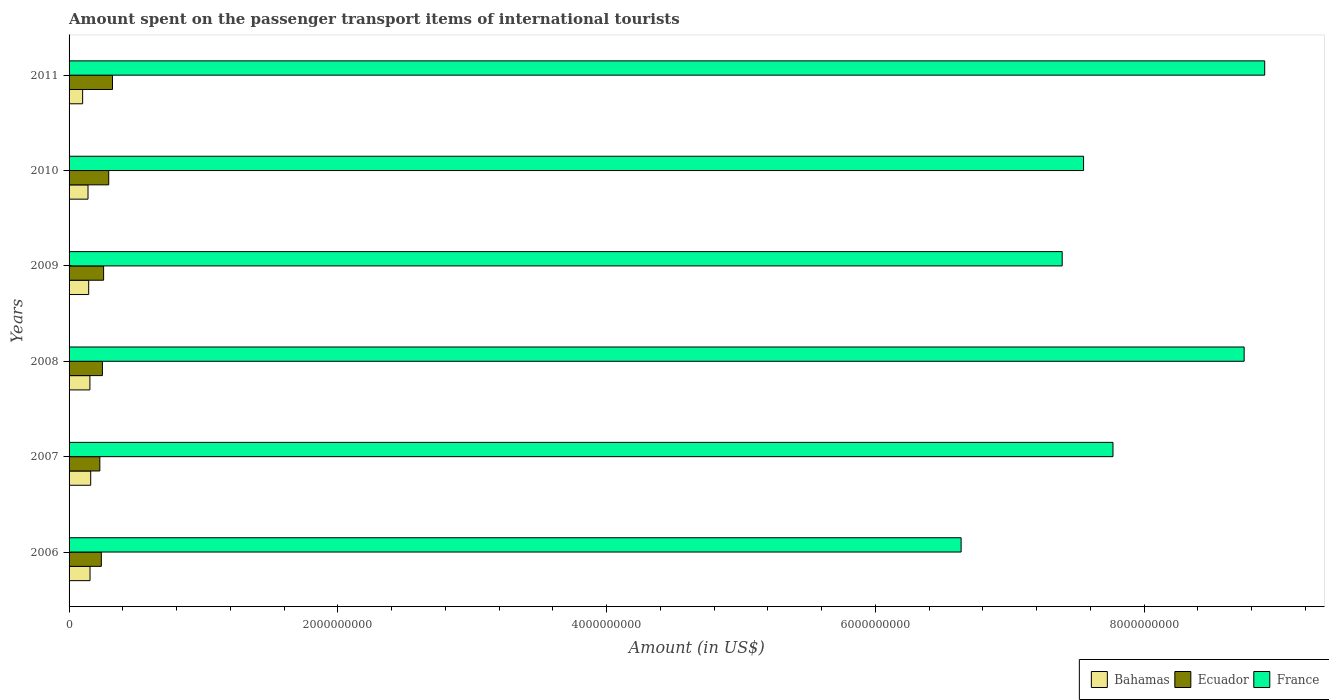How many groups of bars are there?
Keep it short and to the point. 6. Are the number of bars on each tick of the Y-axis equal?
Provide a succinct answer. Yes. How many bars are there on the 3rd tick from the bottom?
Keep it short and to the point. 3. What is the label of the 5th group of bars from the top?
Offer a terse response. 2007. In how many cases, is the number of bars for a given year not equal to the number of legend labels?
Offer a terse response. 0. What is the amount spent on the passenger transport items of international tourists in France in 2007?
Keep it short and to the point. 7.77e+09. Across all years, what is the maximum amount spent on the passenger transport items of international tourists in France?
Make the answer very short. 8.90e+09. Across all years, what is the minimum amount spent on the passenger transport items of international tourists in Ecuador?
Provide a succinct answer. 2.29e+08. In which year was the amount spent on the passenger transport items of international tourists in Bahamas minimum?
Ensure brevity in your answer.  2011. What is the total amount spent on the passenger transport items of international tourists in France in the graph?
Provide a succinct answer. 4.70e+1. What is the difference between the amount spent on the passenger transport items of international tourists in France in 2009 and that in 2011?
Provide a succinct answer. -1.51e+09. What is the difference between the amount spent on the passenger transport items of international tourists in France in 2011 and the amount spent on the passenger transport items of international tourists in Ecuador in 2007?
Offer a terse response. 8.67e+09. What is the average amount spent on the passenger transport items of international tourists in Bahamas per year?
Make the answer very short. 1.43e+08. In the year 2008, what is the difference between the amount spent on the passenger transport items of international tourists in Ecuador and amount spent on the passenger transport items of international tourists in France?
Your answer should be very brief. -8.50e+09. In how many years, is the amount spent on the passenger transport items of international tourists in Ecuador greater than 400000000 US$?
Make the answer very short. 0. What is the ratio of the amount spent on the passenger transport items of international tourists in Bahamas in 2008 to that in 2009?
Your answer should be very brief. 1.06. Is the amount spent on the passenger transport items of international tourists in Bahamas in 2006 less than that in 2011?
Give a very brief answer. No. What is the difference between the highest and the second highest amount spent on the passenger transport items of international tourists in Ecuador?
Your answer should be very brief. 2.80e+07. What is the difference between the highest and the lowest amount spent on the passenger transport items of international tourists in Bahamas?
Your response must be concise. 6.00e+07. What does the 3rd bar from the top in 2008 represents?
Give a very brief answer. Bahamas. What does the 2nd bar from the bottom in 2008 represents?
Your answer should be compact. Ecuador. Is it the case that in every year, the sum of the amount spent on the passenger transport items of international tourists in Ecuador and amount spent on the passenger transport items of international tourists in Bahamas is greater than the amount spent on the passenger transport items of international tourists in France?
Make the answer very short. No. How many years are there in the graph?
Your response must be concise. 6. Are the values on the major ticks of X-axis written in scientific E-notation?
Ensure brevity in your answer.  No. Does the graph contain any zero values?
Provide a short and direct response. No. Does the graph contain grids?
Give a very brief answer. No. Where does the legend appear in the graph?
Provide a short and direct response. Bottom right. How many legend labels are there?
Ensure brevity in your answer.  3. How are the legend labels stacked?
Give a very brief answer. Horizontal. What is the title of the graph?
Offer a very short reply. Amount spent on the passenger transport items of international tourists. What is the label or title of the Y-axis?
Make the answer very short. Years. What is the Amount (in US$) in Bahamas in 2006?
Your response must be concise. 1.56e+08. What is the Amount (in US$) of Ecuador in 2006?
Offer a terse response. 2.40e+08. What is the Amount (in US$) in France in 2006?
Keep it short and to the point. 6.64e+09. What is the Amount (in US$) in Bahamas in 2007?
Provide a short and direct response. 1.61e+08. What is the Amount (in US$) of Ecuador in 2007?
Provide a succinct answer. 2.29e+08. What is the Amount (in US$) in France in 2007?
Ensure brevity in your answer.  7.77e+09. What is the Amount (in US$) in Bahamas in 2008?
Make the answer very short. 1.55e+08. What is the Amount (in US$) of Ecuador in 2008?
Offer a terse response. 2.48e+08. What is the Amount (in US$) in France in 2008?
Ensure brevity in your answer.  8.74e+09. What is the Amount (in US$) of Bahamas in 2009?
Give a very brief answer. 1.46e+08. What is the Amount (in US$) of Ecuador in 2009?
Your response must be concise. 2.57e+08. What is the Amount (in US$) in France in 2009?
Provide a succinct answer. 7.39e+09. What is the Amount (in US$) in Bahamas in 2010?
Offer a terse response. 1.41e+08. What is the Amount (in US$) in Ecuador in 2010?
Your answer should be very brief. 2.95e+08. What is the Amount (in US$) of France in 2010?
Ensure brevity in your answer.  7.55e+09. What is the Amount (in US$) of Bahamas in 2011?
Provide a succinct answer. 1.01e+08. What is the Amount (in US$) in Ecuador in 2011?
Give a very brief answer. 3.23e+08. What is the Amount (in US$) in France in 2011?
Provide a succinct answer. 8.90e+09. Across all years, what is the maximum Amount (in US$) of Bahamas?
Your response must be concise. 1.61e+08. Across all years, what is the maximum Amount (in US$) in Ecuador?
Offer a very short reply. 3.23e+08. Across all years, what is the maximum Amount (in US$) of France?
Your answer should be very brief. 8.90e+09. Across all years, what is the minimum Amount (in US$) of Bahamas?
Provide a short and direct response. 1.01e+08. Across all years, what is the minimum Amount (in US$) of Ecuador?
Offer a terse response. 2.29e+08. Across all years, what is the minimum Amount (in US$) of France?
Your answer should be compact. 6.64e+09. What is the total Amount (in US$) in Bahamas in the graph?
Offer a terse response. 8.60e+08. What is the total Amount (in US$) in Ecuador in the graph?
Offer a terse response. 1.59e+09. What is the total Amount (in US$) of France in the graph?
Give a very brief answer. 4.70e+1. What is the difference between the Amount (in US$) of Bahamas in 2006 and that in 2007?
Keep it short and to the point. -5.00e+06. What is the difference between the Amount (in US$) in Ecuador in 2006 and that in 2007?
Offer a very short reply. 1.10e+07. What is the difference between the Amount (in US$) of France in 2006 and that in 2007?
Your response must be concise. -1.13e+09. What is the difference between the Amount (in US$) of Ecuador in 2006 and that in 2008?
Your answer should be very brief. -8.00e+06. What is the difference between the Amount (in US$) in France in 2006 and that in 2008?
Make the answer very short. -2.11e+09. What is the difference between the Amount (in US$) in Ecuador in 2006 and that in 2009?
Your answer should be very brief. -1.70e+07. What is the difference between the Amount (in US$) in France in 2006 and that in 2009?
Offer a terse response. -7.52e+08. What is the difference between the Amount (in US$) in Bahamas in 2006 and that in 2010?
Offer a very short reply. 1.50e+07. What is the difference between the Amount (in US$) of Ecuador in 2006 and that in 2010?
Your response must be concise. -5.50e+07. What is the difference between the Amount (in US$) in France in 2006 and that in 2010?
Make the answer very short. -9.11e+08. What is the difference between the Amount (in US$) of Bahamas in 2006 and that in 2011?
Make the answer very short. 5.50e+07. What is the difference between the Amount (in US$) of Ecuador in 2006 and that in 2011?
Your answer should be very brief. -8.30e+07. What is the difference between the Amount (in US$) of France in 2006 and that in 2011?
Offer a terse response. -2.26e+09. What is the difference between the Amount (in US$) of Bahamas in 2007 and that in 2008?
Your answer should be compact. 6.00e+06. What is the difference between the Amount (in US$) of Ecuador in 2007 and that in 2008?
Give a very brief answer. -1.90e+07. What is the difference between the Amount (in US$) of France in 2007 and that in 2008?
Your response must be concise. -9.76e+08. What is the difference between the Amount (in US$) of Bahamas in 2007 and that in 2009?
Provide a succinct answer. 1.50e+07. What is the difference between the Amount (in US$) in Ecuador in 2007 and that in 2009?
Offer a terse response. -2.80e+07. What is the difference between the Amount (in US$) of France in 2007 and that in 2009?
Offer a very short reply. 3.78e+08. What is the difference between the Amount (in US$) in Ecuador in 2007 and that in 2010?
Your response must be concise. -6.60e+07. What is the difference between the Amount (in US$) of France in 2007 and that in 2010?
Provide a short and direct response. 2.19e+08. What is the difference between the Amount (in US$) in Bahamas in 2007 and that in 2011?
Provide a succinct answer. 6.00e+07. What is the difference between the Amount (in US$) in Ecuador in 2007 and that in 2011?
Provide a short and direct response. -9.40e+07. What is the difference between the Amount (in US$) in France in 2007 and that in 2011?
Make the answer very short. -1.13e+09. What is the difference between the Amount (in US$) of Bahamas in 2008 and that in 2009?
Offer a very short reply. 9.00e+06. What is the difference between the Amount (in US$) of Ecuador in 2008 and that in 2009?
Your answer should be very brief. -9.00e+06. What is the difference between the Amount (in US$) of France in 2008 and that in 2009?
Provide a short and direct response. 1.35e+09. What is the difference between the Amount (in US$) in Bahamas in 2008 and that in 2010?
Make the answer very short. 1.40e+07. What is the difference between the Amount (in US$) in Ecuador in 2008 and that in 2010?
Make the answer very short. -4.70e+07. What is the difference between the Amount (in US$) of France in 2008 and that in 2010?
Give a very brief answer. 1.20e+09. What is the difference between the Amount (in US$) in Bahamas in 2008 and that in 2011?
Your answer should be compact. 5.40e+07. What is the difference between the Amount (in US$) of Ecuador in 2008 and that in 2011?
Your answer should be very brief. -7.50e+07. What is the difference between the Amount (in US$) of France in 2008 and that in 2011?
Keep it short and to the point. -1.53e+08. What is the difference between the Amount (in US$) of Bahamas in 2009 and that in 2010?
Provide a short and direct response. 5.00e+06. What is the difference between the Amount (in US$) in Ecuador in 2009 and that in 2010?
Keep it short and to the point. -3.80e+07. What is the difference between the Amount (in US$) in France in 2009 and that in 2010?
Provide a succinct answer. -1.59e+08. What is the difference between the Amount (in US$) of Bahamas in 2009 and that in 2011?
Ensure brevity in your answer.  4.50e+07. What is the difference between the Amount (in US$) in Ecuador in 2009 and that in 2011?
Your answer should be very brief. -6.60e+07. What is the difference between the Amount (in US$) of France in 2009 and that in 2011?
Offer a very short reply. -1.51e+09. What is the difference between the Amount (in US$) of Bahamas in 2010 and that in 2011?
Ensure brevity in your answer.  4.00e+07. What is the difference between the Amount (in US$) in Ecuador in 2010 and that in 2011?
Your answer should be very brief. -2.80e+07. What is the difference between the Amount (in US$) in France in 2010 and that in 2011?
Offer a terse response. -1.35e+09. What is the difference between the Amount (in US$) in Bahamas in 2006 and the Amount (in US$) in Ecuador in 2007?
Your response must be concise. -7.30e+07. What is the difference between the Amount (in US$) in Bahamas in 2006 and the Amount (in US$) in France in 2007?
Give a very brief answer. -7.61e+09. What is the difference between the Amount (in US$) in Ecuador in 2006 and the Amount (in US$) in France in 2007?
Make the answer very short. -7.53e+09. What is the difference between the Amount (in US$) of Bahamas in 2006 and the Amount (in US$) of Ecuador in 2008?
Give a very brief answer. -9.20e+07. What is the difference between the Amount (in US$) in Bahamas in 2006 and the Amount (in US$) in France in 2008?
Give a very brief answer. -8.59e+09. What is the difference between the Amount (in US$) of Ecuador in 2006 and the Amount (in US$) of France in 2008?
Provide a short and direct response. -8.50e+09. What is the difference between the Amount (in US$) of Bahamas in 2006 and the Amount (in US$) of Ecuador in 2009?
Provide a succinct answer. -1.01e+08. What is the difference between the Amount (in US$) in Bahamas in 2006 and the Amount (in US$) in France in 2009?
Offer a terse response. -7.23e+09. What is the difference between the Amount (in US$) of Ecuador in 2006 and the Amount (in US$) of France in 2009?
Your answer should be compact. -7.15e+09. What is the difference between the Amount (in US$) of Bahamas in 2006 and the Amount (in US$) of Ecuador in 2010?
Your response must be concise. -1.39e+08. What is the difference between the Amount (in US$) of Bahamas in 2006 and the Amount (in US$) of France in 2010?
Provide a succinct answer. -7.39e+09. What is the difference between the Amount (in US$) of Ecuador in 2006 and the Amount (in US$) of France in 2010?
Your response must be concise. -7.31e+09. What is the difference between the Amount (in US$) of Bahamas in 2006 and the Amount (in US$) of Ecuador in 2011?
Make the answer very short. -1.67e+08. What is the difference between the Amount (in US$) of Bahamas in 2006 and the Amount (in US$) of France in 2011?
Your answer should be compact. -8.74e+09. What is the difference between the Amount (in US$) of Ecuador in 2006 and the Amount (in US$) of France in 2011?
Provide a short and direct response. -8.66e+09. What is the difference between the Amount (in US$) of Bahamas in 2007 and the Amount (in US$) of Ecuador in 2008?
Your response must be concise. -8.70e+07. What is the difference between the Amount (in US$) of Bahamas in 2007 and the Amount (in US$) of France in 2008?
Make the answer very short. -8.58e+09. What is the difference between the Amount (in US$) of Ecuador in 2007 and the Amount (in US$) of France in 2008?
Keep it short and to the point. -8.52e+09. What is the difference between the Amount (in US$) of Bahamas in 2007 and the Amount (in US$) of Ecuador in 2009?
Offer a very short reply. -9.60e+07. What is the difference between the Amount (in US$) in Bahamas in 2007 and the Amount (in US$) in France in 2009?
Your response must be concise. -7.23e+09. What is the difference between the Amount (in US$) in Ecuador in 2007 and the Amount (in US$) in France in 2009?
Give a very brief answer. -7.16e+09. What is the difference between the Amount (in US$) in Bahamas in 2007 and the Amount (in US$) in Ecuador in 2010?
Your answer should be compact. -1.34e+08. What is the difference between the Amount (in US$) of Bahamas in 2007 and the Amount (in US$) of France in 2010?
Provide a short and direct response. -7.39e+09. What is the difference between the Amount (in US$) in Ecuador in 2007 and the Amount (in US$) in France in 2010?
Provide a short and direct response. -7.32e+09. What is the difference between the Amount (in US$) of Bahamas in 2007 and the Amount (in US$) of Ecuador in 2011?
Your answer should be very brief. -1.62e+08. What is the difference between the Amount (in US$) of Bahamas in 2007 and the Amount (in US$) of France in 2011?
Make the answer very short. -8.74e+09. What is the difference between the Amount (in US$) of Ecuador in 2007 and the Amount (in US$) of France in 2011?
Keep it short and to the point. -8.67e+09. What is the difference between the Amount (in US$) of Bahamas in 2008 and the Amount (in US$) of Ecuador in 2009?
Give a very brief answer. -1.02e+08. What is the difference between the Amount (in US$) of Bahamas in 2008 and the Amount (in US$) of France in 2009?
Provide a succinct answer. -7.24e+09. What is the difference between the Amount (in US$) of Ecuador in 2008 and the Amount (in US$) of France in 2009?
Your answer should be very brief. -7.14e+09. What is the difference between the Amount (in US$) of Bahamas in 2008 and the Amount (in US$) of Ecuador in 2010?
Offer a very short reply. -1.40e+08. What is the difference between the Amount (in US$) in Bahamas in 2008 and the Amount (in US$) in France in 2010?
Your response must be concise. -7.39e+09. What is the difference between the Amount (in US$) of Ecuador in 2008 and the Amount (in US$) of France in 2010?
Your answer should be very brief. -7.30e+09. What is the difference between the Amount (in US$) of Bahamas in 2008 and the Amount (in US$) of Ecuador in 2011?
Provide a succinct answer. -1.68e+08. What is the difference between the Amount (in US$) of Bahamas in 2008 and the Amount (in US$) of France in 2011?
Offer a very short reply. -8.74e+09. What is the difference between the Amount (in US$) of Ecuador in 2008 and the Amount (in US$) of France in 2011?
Offer a very short reply. -8.65e+09. What is the difference between the Amount (in US$) in Bahamas in 2009 and the Amount (in US$) in Ecuador in 2010?
Your answer should be compact. -1.49e+08. What is the difference between the Amount (in US$) in Bahamas in 2009 and the Amount (in US$) in France in 2010?
Give a very brief answer. -7.40e+09. What is the difference between the Amount (in US$) of Ecuador in 2009 and the Amount (in US$) of France in 2010?
Provide a succinct answer. -7.29e+09. What is the difference between the Amount (in US$) in Bahamas in 2009 and the Amount (in US$) in Ecuador in 2011?
Your answer should be very brief. -1.77e+08. What is the difference between the Amount (in US$) in Bahamas in 2009 and the Amount (in US$) in France in 2011?
Provide a succinct answer. -8.75e+09. What is the difference between the Amount (in US$) in Ecuador in 2009 and the Amount (in US$) in France in 2011?
Your answer should be compact. -8.64e+09. What is the difference between the Amount (in US$) of Bahamas in 2010 and the Amount (in US$) of Ecuador in 2011?
Keep it short and to the point. -1.82e+08. What is the difference between the Amount (in US$) in Bahamas in 2010 and the Amount (in US$) in France in 2011?
Give a very brief answer. -8.76e+09. What is the difference between the Amount (in US$) of Ecuador in 2010 and the Amount (in US$) of France in 2011?
Ensure brevity in your answer.  -8.60e+09. What is the average Amount (in US$) of Bahamas per year?
Your answer should be compact. 1.43e+08. What is the average Amount (in US$) in Ecuador per year?
Make the answer very short. 2.65e+08. What is the average Amount (in US$) of France per year?
Ensure brevity in your answer.  7.83e+09. In the year 2006, what is the difference between the Amount (in US$) in Bahamas and Amount (in US$) in Ecuador?
Provide a succinct answer. -8.40e+07. In the year 2006, what is the difference between the Amount (in US$) in Bahamas and Amount (in US$) in France?
Your answer should be very brief. -6.48e+09. In the year 2006, what is the difference between the Amount (in US$) of Ecuador and Amount (in US$) of France?
Your answer should be compact. -6.40e+09. In the year 2007, what is the difference between the Amount (in US$) of Bahamas and Amount (in US$) of Ecuador?
Your response must be concise. -6.80e+07. In the year 2007, what is the difference between the Amount (in US$) of Bahamas and Amount (in US$) of France?
Your answer should be compact. -7.61e+09. In the year 2007, what is the difference between the Amount (in US$) of Ecuador and Amount (in US$) of France?
Offer a terse response. -7.54e+09. In the year 2008, what is the difference between the Amount (in US$) of Bahamas and Amount (in US$) of Ecuador?
Provide a short and direct response. -9.30e+07. In the year 2008, what is the difference between the Amount (in US$) of Bahamas and Amount (in US$) of France?
Offer a very short reply. -8.59e+09. In the year 2008, what is the difference between the Amount (in US$) of Ecuador and Amount (in US$) of France?
Ensure brevity in your answer.  -8.50e+09. In the year 2009, what is the difference between the Amount (in US$) in Bahamas and Amount (in US$) in Ecuador?
Offer a very short reply. -1.11e+08. In the year 2009, what is the difference between the Amount (in US$) in Bahamas and Amount (in US$) in France?
Your response must be concise. -7.24e+09. In the year 2009, what is the difference between the Amount (in US$) in Ecuador and Amount (in US$) in France?
Provide a short and direct response. -7.13e+09. In the year 2010, what is the difference between the Amount (in US$) in Bahamas and Amount (in US$) in Ecuador?
Give a very brief answer. -1.54e+08. In the year 2010, what is the difference between the Amount (in US$) of Bahamas and Amount (in US$) of France?
Provide a succinct answer. -7.41e+09. In the year 2010, what is the difference between the Amount (in US$) of Ecuador and Amount (in US$) of France?
Offer a terse response. -7.25e+09. In the year 2011, what is the difference between the Amount (in US$) in Bahamas and Amount (in US$) in Ecuador?
Make the answer very short. -2.22e+08. In the year 2011, what is the difference between the Amount (in US$) in Bahamas and Amount (in US$) in France?
Ensure brevity in your answer.  -8.80e+09. In the year 2011, what is the difference between the Amount (in US$) of Ecuador and Amount (in US$) of France?
Make the answer very short. -8.57e+09. What is the ratio of the Amount (in US$) in Bahamas in 2006 to that in 2007?
Give a very brief answer. 0.97. What is the ratio of the Amount (in US$) in Ecuador in 2006 to that in 2007?
Your answer should be very brief. 1.05. What is the ratio of the Amount (in US$) of France in 2006 to that in 2007?
Your answer should be compact. 0.85. What is the ratio of the Amount (in US$) of Ecuador in 2006 to that in 2008?
Your answer should be compact. 0.97. What is the ratio of the Amount (in US$) of France in 2006 to that in 2008?
Provide a short and direct response. 0.76. What is the ratio of the Amount (in US$) of Bahamas in 2006 to that in 2009?
Your answer should be very brief. 1.07. What is the ratio of the Amount (in US$) of Ecuador in 2006 to that in 2009?
Your answer should be compact. 0.93. What is the ratio of the Amount (in US$) of France in 2006 to that in 2009?
Keep it short and to the point. 0.9. What is the ratio of the Amount (in US$) of Bahamas in 2006 to that in 2010?
Offer a very short reply. 1.11. What is the ratio of the Amount (in US$) in Ecuador in 2006 to that in 2010?
Your response must be concise. 0.81. What is the ratio of the Amount (in US$) of France in 2006 to that in 2010?
Your answer should be very brief. 0.88. What is the ratio of the Amount (in US$) in Bahamas in 2006 to that in 2011?
Provide a succinct answer. 1.54. What is the ratio of the Amount (in US$) in Ecuador in 2006 to that in 2011?
Your answer should be compact. 0.74. What is the ratio of the Amount (in US$) in France in 2006 to that in 2011?
Keep it short and to the point. 0.75. What is the ratio of the Amount (in US$) of Bahamas in 2007 to that in 2008?
Offer a very short reply. 1.04. What is the ratio of the Amount (in US$) in Ecuador in 2007 to that in 2008?
Make the answer very short. 0.92. What is the ratio of the Amount (in US$) of France in 2007 to that in 2008?
Make the answer very short. 0.89. What is the ratio of the Amount (in US$) of Bahamas in 2007 to that in 2009?
Make the answer very short. 1.1. What is the ratio of the Amount (in US$) of Ecuador in 2007 to that in 2009?
Make the answer very short. 0.89. What is the ratio of the Amount (in US$) in France in 2007 to that in 2009?
Offer a very short reply. 1.05. What is the ratio of the Amount (in US$) in Bahamas in 2007 to that in 2010?
Offer a very short reply. 1.14. What is the ratio of the Amount (in US$) in Ecuador in 2007 to that in 2010?
Offer a terse response. 0.78. What is the ratio of the Amount (in US$) in France in 2007 to that in 2010?
Offer a terse response. 1.03. What is the ratio of the Amount (in US$) of Bahamas in 2007 to that in 2011?
Your answer should be compact. 1.59. What is the ratio of the Amount (in US$) of Ecuador in 2007 to that in 2011?
Offer a terse response. 0.71. What is the ratio of the Amount (in US$) of France in 2007 to that in 2011?
Provide a short and direct response. 0.87. What is the ratio of the Amount (in US$) of Bahamas in 2008 to that in 2009?
Your response must be concise. 1.06. What is the ratio of the Amount (in US$) of Ecuador in 2008 to that in 2009?
Keep it short and to the point. 0.96. What is the ratio of the Amount (in US$) of France in 2008 to that in 2009?
Keep it short and to the point. 1.18. What is the ratio of the Amount (in US$) of Bahamas in 2008 to that in 2010?
Give a very brief answer. 1.1. What is the ratio of the Amount (in US$) in Ecuador in 2008 to that in 2010?
Offer a terse response. 0.84. What is the ratio of the Amount (in US$) of France in 2008 to that in 2010?
Offer a terse response. 1.16. What is the ratio of the Amount (in US$) of Bahamas in 2008 to that in 2011?
Provide a short and direct response. 1.53. What is the ratio of the Amount (in US$) of Ecuador in 2008 to that in 2011?
Offer a very short reply. 0.77. What is the ratio of the Amount (in US$) of France in 2008 to that in 2011?
Provide a short and direct response. 0.98. What is the ratio of the Amount (in US$) of Bahamas in 2009 to that in 2010?
Provide a short and direct response. 1.04. What is the ratio of the Amount (in US$) in Ecuador in 2009 to that in 2010?
Your response must be concise. 0.87. What is the ratio of the Amount (in US$) of France in 2009 to that in 2010?
Provide a short and direct response. 0.98. What is the ratio of the Amount (in US$) of Bahamas in 2009 to that in 2011?
Your answer should be very brief. 1.45. What is the ratio of the Amount (in US$) in Ecuador in 2009 to that in 2011?
Ensure brevity in your answer.  0.8. What is the ratio of the Amount (in US$) of France in 2009 to that in 2011?
Ensure brevity in your answer.  0.83. What is the ratio of the Amount (in US$) in Bahamas in 2010 to that in 2011?
Keep it short and to the point. 1.4. What is the ratio of the Amount (in US$) of Ecuador in 2010 to that in 2011?
Offer a terse response. 0.91. What is the ratio of the Amount (in US$) in France in 2010 to that in 2011?
Offer a terse response. 0.85. What is the difference between the highest and the second highest Amount (in US$) in Bahamas?
Give a very brief answer. 5.00e+06. What is the difference between the highest and the second highest Amount (in US$) in Ecuador?
Give a very brief answer. 2.80e+07. What is the difference between the highest and the second highest Amount (in US$) of France?
Make the answer very short. 1.53e+08. What is the difference between the highest and the lowest Amount (in US$) in Bahamas?
Provide a succinct answer. 6.00e+07. What is the difference between the highest and the lowest Amount (in US$) of Ecuador?
Keep it short and to the point. 9.40e+07. What is the difference between the highest and the lowest Amount (in US$) of France?
Provide a succinct answer. 2.26e+09. 